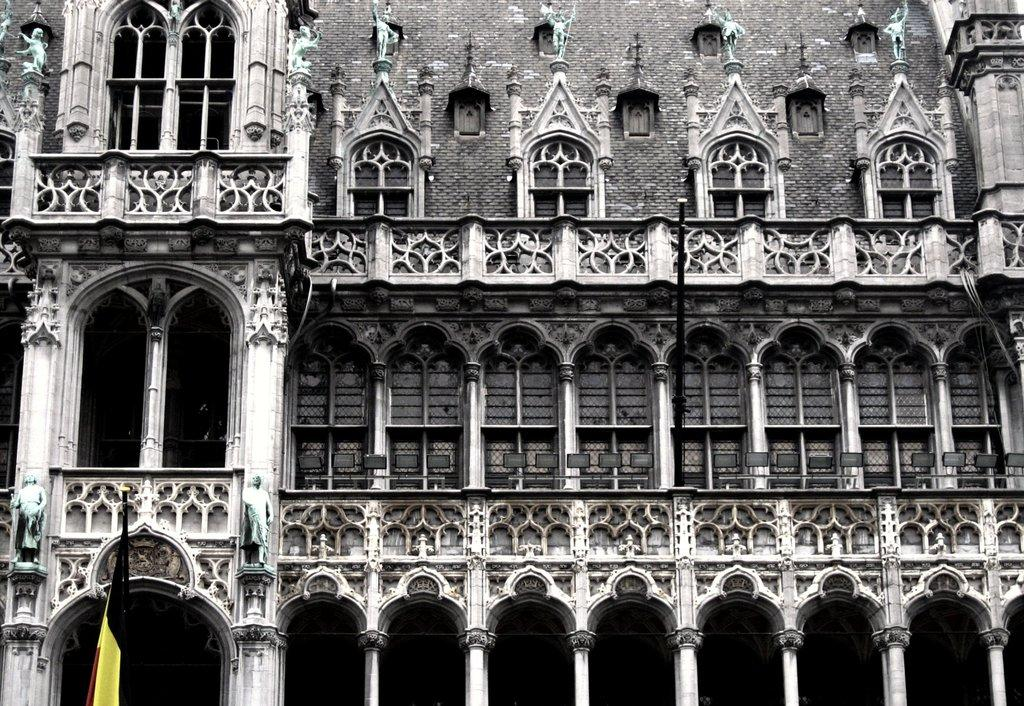What is located on the left side of the image? There is a flag on the left side of the image. What can be seen in the background of the image? There are sculptures, buildings, windows, and pillars in the background of the image. What type of soap is being used to clean the coal in the image? There is no soap or coal present in the image. What type of education is being taught in the image? There is no indication of any educational activity in the image. 